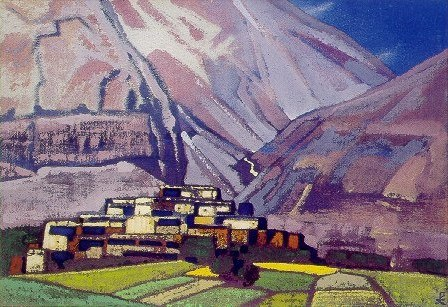Could you interpret the mood or atmosphere created by the artist in this painting? The artist has masterfully created a mood of peacefulness and isolation. The use of bright, contrasting colors draws the viewer into a landscape that feels both idyllic and remote. The dramatic mountains in the background, paired with the tranquil village, juxtapose the grandeur of nature with human settlement. The overall atmosphere might suggest a harmony between mankind and nature, invoking feelings of awe and serenity. 